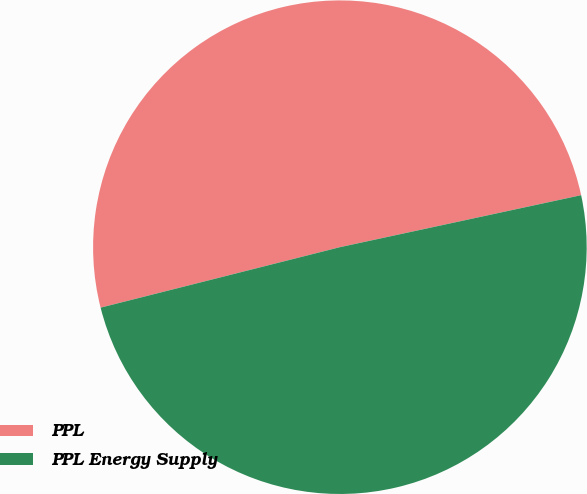<chart> <loc_0><loc_0><loc_500><loc_500><pie_chart><fcel>PPL<fcel>PPL Energy Supply<nl><fcel>50.56%<fcel>49.44%<nl></chart> 